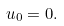Convert formula to latex. <formula><loc_0><loc_0><loc_500><loc_500>u _ { 0 } = 0 .</formula> 